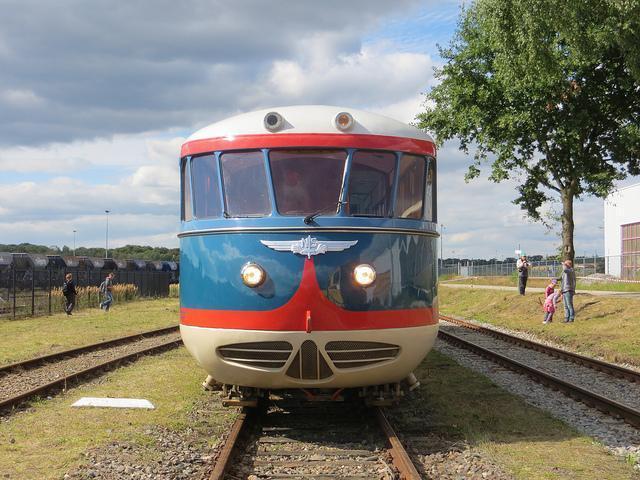How many tracks are in the photo?
Give a very brief answer. 3. How many lights on the train?
Give a very brief answer. 2. How many people are standing by the tree?
Give a very brief answer. 3. How many trains are visible?
Give a very brief answer. 1. How many motorcycles are parked off the street?
Give a very brief answer. 0. 